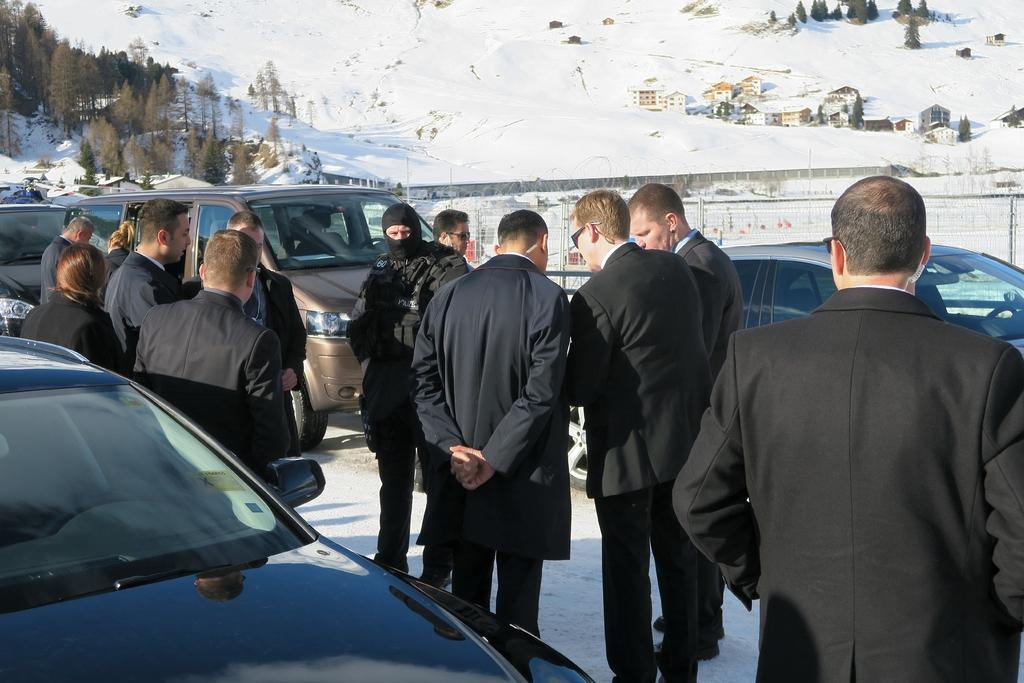Where was the picture taken? The picture was clicked outside a city. What can be seen in the foreground of the image? There are cars, people, and fencing in the foreground of the image. What is visible in the center of the image? There are trees, houses, and snow in the center of the image. What type of suit is the person wearing in the image? There is no person wearing a suit in the image. What kind of curtain can be seen hanging from the trees in the image? There are no curtains present in the image; it features trees, houses, and snow. Is there a throne visible in the center of the image? There is no throne present in the image. 